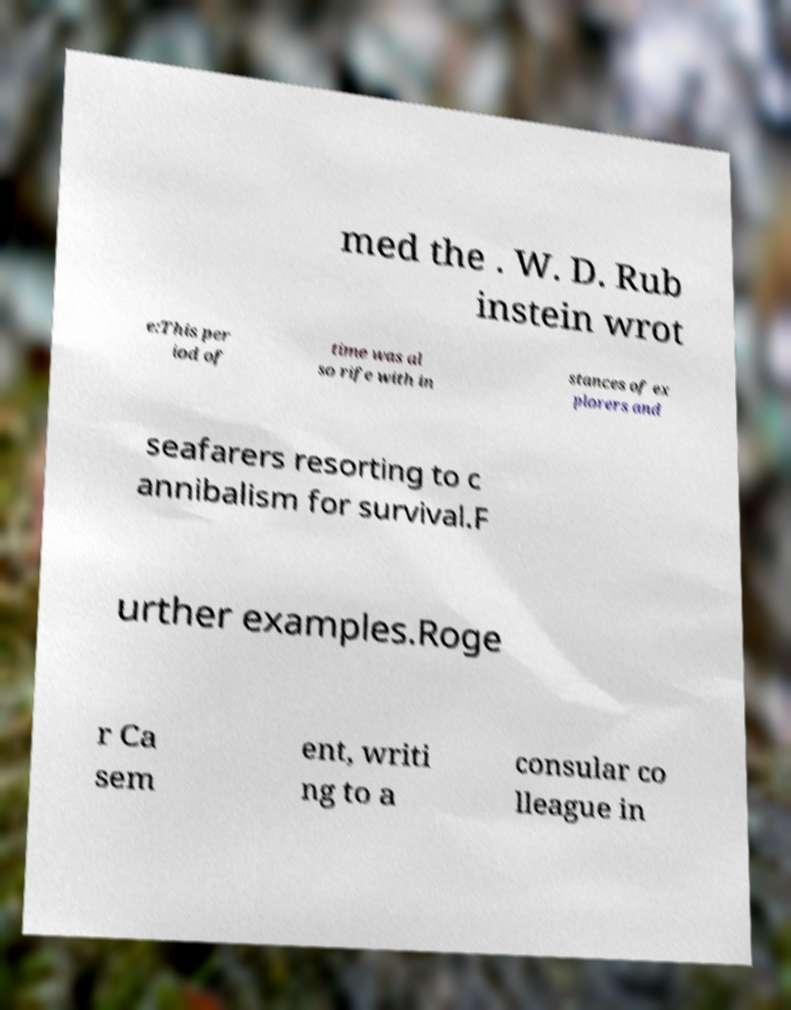Please identify and transcribe the text found in this image. med the . W. D. Rub instein wrot e:This per iod of time was al so rife with in stances of ex plorers and seafarers resorting to c annibalism for survival.F urther examples.Roge r Ca sem ent, writi ng to a consular co lleague in 